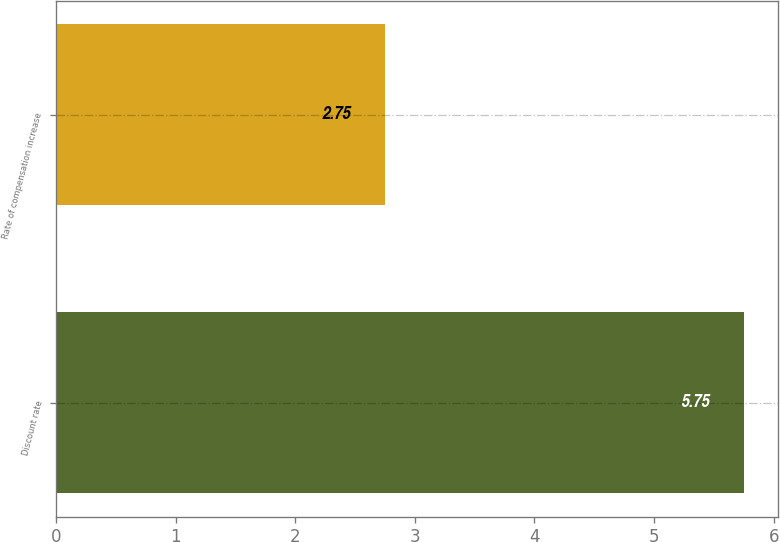Convert chart. <chart><loc_0><loc_0><loc_500><loc_500><bar_chart><fcel>Discount rate<fcel>Rate of compensation increase<nl><fcel>5.75<fcel>2.75<nl></chart> 